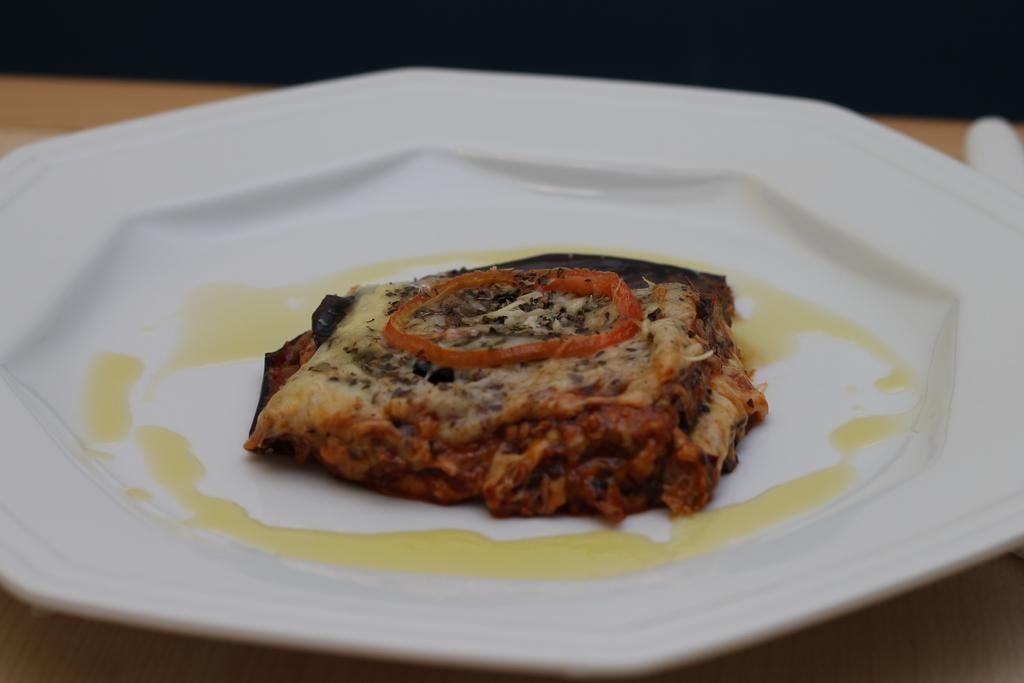How would you summarize this image in a sentence or two? In this image, we can see a food item in the plate, placed on the table. 